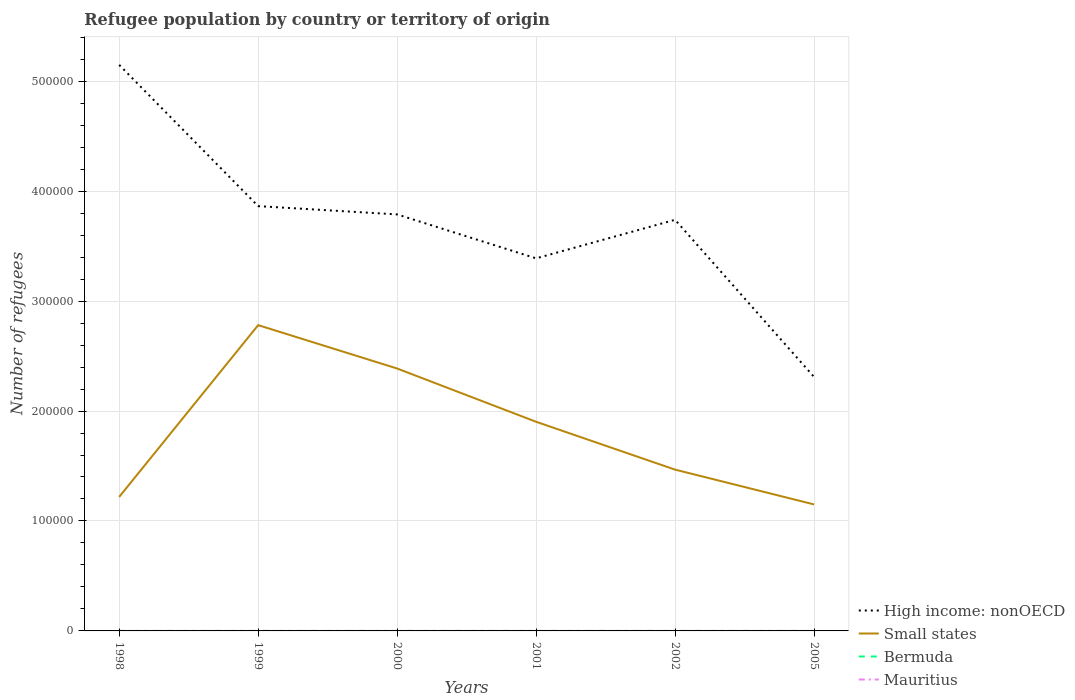How many different coloured lines are there?
Ensure brevity in your answer.  4. Is the number of lines equal to the number of legend labels?
Provide a short and direct response. Yes. Across all years, what is the maximum number of refugees in Mauritius?
Make the answer very short. 8. What is the total number of refugees in Small states in the graph?
Give a very brief answer. 1.24e+05. What is the difference between the highest and the second highest number of refugees in Mauritius?
Your response must be concise. 35. What is the difference between the highest and the lowest number of refugees in Small states?
Keep it short and to the point. 3. Is the number of refugees in Small states strictly greater than the number of refugees in Bermuda over the years?
Give a very brief answer. No. What is the difference between two consecutive major ticks on the Y-axis?
Provide a short and direct response. 1.00e+05. Are the values on the major ticks of Y-axis written in scientific E-notation?
Provide a short and direct response. No. Does the graph contain any zero values?
Provide a short and direct response. No. Does the graph contain grids?
Your response must be concise. Yes. Where does the legend appear in the graph?
Your response must be concise. Bottom right. How many legend labels are there?
Provide a succinct answer. 4. What is the title of the graph?
Offer a very short reply. Refugee population by country or territory of origin. Does "Luxembourg" appear as one of the legend labels in the graph?
Provide a short and direct response. No. What is the label or title of the X-axis?
Your answer should be very brief. Years. What is the label or title of the Y-axis?
Offer a terse response. Number of refugees. What is the Number of refugees of High income: nonOECD in 1998?
Offer a terse response. 5.15e+05. What is the Number of refugees of Small states in 1998?
Your answer should be compact. 1.22e+05. What is the Number of refugees of High income: nonOECD in 1999?
Your answer should be very brief. 3.86e+05. What is the Number of refugees of Small states in 1999?
Give a very brief answer. 2.78e+05. What is the Number of refugees in Bermuda in 1999?
Offer a terse response. 1. What is the Number of refugees in Mauritius in 1999?
Offer a very short reply. 8. What is the Number of refugees of High income: nonOECD in 2000?
Make the answer very short. 3.79e+05. What is the Number of refugees in Small states in 2000?
Offer a very short reply. 2.39e+05. What is the Number of refugees of High income: nonOECD in 2001?
Your response must be concise. 3.39e+05. What is the Number of refugees in Small states in 2001?
Offer a terse response. 1.90e+05. What is the Number of refugees in High income: nonOECD in 2002?
Offer a terse response. 3.74e+05. What is the Number of refugees in Small states in 2002?
Your answer should be compact. 1.47e+05. What is the Number of refugees in Bermuda in 2002?
Make the answer very short. 1. What is the Number of refugees of Mauritius in 2002?
Your answer should be compact. 43. What is the Number of refugees in High income: nonOECD in 2005?
Give a very brief answer. 2.31e+05. What is the Number of refugees of Small states in 2005?
Provide a short and direct response. 1.15e+05. What is the Number of refugees in Mauritius in 2005?
Your answer should be compact. 27. Across all years, what is the maximum Number of refugees of High income: nonOECD?
Make the answer very short. 5.15e+05. Across all years, what is the maximum Number of refugees of Small states?
Make the answer very short. 2.78e+05. Across all years, what is the maximum Number of refugees of Bermuda?
Your answer should be very brief. 2. Across all years, what is the minimum Number of refugees in High income: nonOECD?
Provide a succinct answer. 2.31e+05. Across all years, what is the minimum Number of refugees of Small states?
Give a very brief answer. 1.15e+05. Across all years, what is the minimum Number of refugees of Bermuda?
Ensure brevity in your answer.  1. What is the total Number of refugees in High income: nonOECD in the graph?
Provide a short and direct response. 2.22e+06. What is the total Number of refugees of Small states in the graph?
Give a very brief answer. 1.09e+06. What is the total Number of refugees in Bermuda in the graph?
Give a very brief answer. 7. What is the total Number of refugees of Mauritius in the graph?
Provide a succinct answer. 163. What is the difference between the Number of refugees of High income: nonOECD in 1998 and that in 1999?
Provide a succinct answer. 1.28e+05. What is the difference between the Number of refugees in Small states in 1998 and that in 1999?
Your response must be concise. -1.56e+05. What is the difference between the Number of refugees of Bermuda in 1998 and that in 1999?
Ensure brevity in your answer.  0. What is the difference between the Number of refugees of Mauritius in 1998 and that in 1999?
Offer a very short reply. 7. What is the difference between the Number of refugees in High income: nonOECD in 1998 and that in 2000?
Provide a succinct answer. 1.36e+05. What is the difference between the Number of refugees of Small states in 1998 and that in 2000?
Provide a succinct answer. -1.17e+05. What is the difference between the Number of refugees of Bermuda in 1998 and that in 2000?
Offer a terse response. 0. What is the difference between the Number of refugees in High income: nonOECD in 1998 and that in 2001?
Your response must be concise. 1.76e+05. What is the difference between the Number of refugees of Small states in 1998 and that in 2001?
Provide a succinct answer. -6.83e+04. What is the difference between the Number of refugees of Bermuda in 1998 and that in 2001?
Keep it short and to the point. 0. What is the difference between the Number of refugees of High income: nonOECD in 1998 and that in 2002?
Offer a terse response. 1.41e+05. What is the difference between the Number of refugees of Small states in 1998 and that in 2002?
Offer a very short reply. -2.48e+04. What is the difference between the Number of refugees in Mauritius in 1998 and that in 2002?
Provide a short and direct response. -28. What is the difference between the Number of refugees of High income: nonOECD in 1998 and that in 2005?
Offer a very short reply. 2.84e+05. What is the difference between the Number of refugees in Small states in 1998 and that in 2005?
Give a very brief answer. 6827. What is the difference between the Number of refugees of Bermuda in 1998 and that in 2005?
Ensure brevity in your answer.  -1. What is the difference between the Number of refugees in High income: nonOECD in 1999 and that in 2000?
Provide a succinct answer. 7527. What is the difference between the Number of refugees in Small states in 1999 and that in 2000?
Make the answer very short. 3.95e+04. What is the difference between the Number of refugees of High income: nonOECD in 1999 and that in 2001?
Make the answer very short. 4.75e+04. What is the difference between the Number of refugees of Small states in 1999 and that in 2001?
Your response must be concise. 8.79e+04. What is the difference between the Number of refugees of Mauritius in 1999 and that in 2001?
Give a very brief answer. -27. What is the difference between the Number of refugees of High income: nonOECD in 1999 and that in 2002?
Your response must be concise. 1.24e+04. What is the difference between the Number of refugees of Small states in 1999 and that in 2002?
Make the answer very short. 1.31e+05. What is the difference between the Number of refugees in Bermuda in 1999 and that in 2002?
Your response must be concise. 0. What is the difference between the Number of refugees of Mauritius in 1999 and that in 2002?
Give a very brief answer. -35. What is the difference between the Number of refugees of High income: nonOECD in 1999 and that in 2005?
Keep it short and to the point. 1.55e+05. What is the difference between the Number of refugees of Small states in 1999 and that in 2005?
Provide a short and direct response. 1.63e+05. What is the difference between the Number of refugees of Mauritius in 1999 and that in 2005?
Your answer should be compact. -19. What is the difference between the Number of refugees in High income: nonOECD in 2000 and that in 2001?
Your response must be concise. 4.00e+04. What is the difference between the Number of refugees in Small states in 2000 and that in 2001?
Offer a very short reply. 4.84e+04. What is the difference between the Number of refugees of Bermuda in 2000 and that in 2001?
Provide a succinct answer. 0. What is the difference between the Number of refugees of High income: nonOECD in 2000 and that in 2002?
Your answer should be compact. 4901. What is the difference between the Number of refugees in Small states in 2000 and that in 2002?
Keep it short and to the point. 9.20e+04. What is the difference between the Number of refugees of Bermuda in 2000 and that in 2002?
Ensure brevity in your answer.  0. What is the difference between the Number of refugees in Mauritius in 2000 and that in 2002?
Make the answer very short. -8. What is the difference between the Number of refugees of High income: nonOECD in 2000 and that in 2005?
Give a very brief answer. 1.48e+05. What is the difference between the Number of refugees of Small states in 2000 and that in 2005?
Provide a short and direct response. 1.24e+05. What is the difference between the Number of refugees of Mauritius in 2000 and that in 2005?
Give a very brief answer. 8. What is the difference between the Number of refugees of High income: nonOECD in 2001 and that in 2002?
Your answer should be very brief. -3.51e+04. What is the difference between the Number of refugees of Small states in 2001 and that in 2002?
Give a very brief answer. 4.35e+04. What is the difference between the Number of refugees of High income: nonOECD in 2001 and that in 2005?
Your answer should be compact. 1.08e+05. What is the difference between the Number of refugees in Small states in 2001 and that in 2005?
Your answer should be very brief. 7.52e+04. What is the difference between the Number of refugees of High income: nonOECD in 2002 and that in 2005?
Your answer should be very brief. 1.43e+05. What is the difference between the Number of refugees of Small states in 2002 and that in 2005?
Offer a terse response. 3.16e+04. What is the difference between the Number of refugees of Bermuda in 2002 and that in 2005?
Offer a very short reply. -1. What is the difference between the Number of refugees in High income: nonOECD in 1998 and the Number of refugees in Small states in 1999?
Offer a terse response. 2.37e+05. What is the difference between the Number of refugees in High income: nonOECD in 1998 and the Number of refugees in Bermuda in 1999?
Your answer should be compact. 5.15e+05. What is the difference between the Number of refugees of High income: nonOECD in 1998 and the Number of refugees of Mauritius in 1999?
Offer a very short reply. 5.15e+05. What is the difference between the Number of refugees in Small states in 1998 and the Number of refugees in Bermuda in 1999?
Your answer should be very brief. 1.22e+05. What is the difference between the Number of refugees of Small states in 1998 and the Number of refugees of Mauritius in 1999?
Give a very brief answer. 1.22e+05. What is the difference between the Number of refugees of High income: nonOECD in 1998 and the Number of refugees of Small states in 2000?
Provide a succinct answer. 2.76e+05. What is the difference between the Number of refugees in High income: nonOECD in 1998 and the Number of refugees in Bermuda in 2000?
Give a very brief answer. 5.15e+05. What is the difference between the Number of refugees of High income: nonOECD in 1998 and the Number of refugees of Mauritius in 2000?
Your response must be concise. 5.15e+05. What is the difference between the Number of refugees in Small states in 1998 and the Number of refugees in Bermuda in 2000?
Offer a terse response. 1.22e+05. What is the difference between the Number of refugees in Small states in 1998 and the Number of refugees in Mauritius in 2000?
Offer a very short reply. 1.22e+05. What is the difference between the Number of refugees of Bermuda in 1998 and the Number of refugees of Mauritius in 2000?
Ensure brevity in your answer.  -34. What is the difference between the Number of refugees of High income: nonOECD in 1998 and the Number of refugees of Small states in 2001?
Your response must be concise. 3.25e+05. What is the difference between the Number of refugees of High income: nonOECD in 1998 and the Number of refugees of Bermuda in 2001?
Offer a terse response. 5.15e+05. What is the difference between the Number of refugees of High income: nonOECD in 1998 and the Number of refugees of Mauritius in 2001?
Give a very brief answer. 5.15e+05. What is the difference between the Number of refugees of Small states in 1998 and the Number of refugees of Bermuda in 2001?
Offer a terse response. 1.22e+05. What is the difference between the Number of refugees of Small states in 1998 and the Number of refugees of Mauritius in 2001?
Provide a succinct answer. 1.22e+05. What is the difference between the Number of refugees of Bermuda in 1998 and the Number of refugees of Mauritius in 2001?
Your answer should be compact. -34. What is the difference between the Number of refugees of High income: nonOECD in 1998 and the Number of refugees of Small states in 2002?
Keep it short and to the point. 3.68e+05. What is the difference between the Number of refugees in High income: nonOECD in 1998 and the Number of refugees in Bermuda in 2002?
Your answer should be very brief. 5.15e+05. What is the difference between the Number of refugees of High income: nonOECD in 1998 and the Number of refugees of Mauritius in 2002?
Provide a short and direct response. 5.15e+05. What is the difference between the Number of refugees in Small states in 1998 and the Number of refugees in Bermuda in 2002?
Make the answer very short. 1.22e+05. What is the difference between the Number of refugees of Small states in 1998 and the Number of refugees of Mauritius in 2002?
Make the answer very short. 1.22e+05. What is the difference between the Number of refugees of Bermuda in 1998 and the Number of refugees of Mauritius in 2002?
Your answer should be compact. -42. What is the difference between the Number of refugees of High income: nonOECD in 1998 and the Number of refugees of Small states in 2005?
Make the answer very short. 4.00e+05. What is the difference between the Number of refugees in High income: nonOECD in 1998 and the Number of refugees in Bermuda in 2005?
Offer a terse response. 5.15e+05. What is the difference between the Number of refugees in High income: nonOECD in 1998 and the Number of refugees in Mauritius in 2005?
Give a very brief answer. 5.15e+05. What is the difference between the Number of refugees of Small states in 1998 and the Number of refugees of Bermuda in 2005?
Offer a terse response. 1.22e+05. What is the difference between the Number of refugees in Small states in 1998 and the Number of refugees in Mauritius in 2005?
Make the answer very short. 1.22e+05. What is the difference between the Number of refugees of Bermuda in 1998 and the Number of refugees of Mauritius in 2005?
Make the answer very short. -26. What is the difference between the Number of refugees of High income: nonOECD in 1999 and the Number of refugees of Small states in 2000?
Your response must be concise. 1.48e+05. What is the difference between the Number of refugees in High income: nonOECD in 1999 and the Number of refugees in Bermuda in 2000?
Make the answer very short. 3.86e+05. What is the difference between the Number of refugees in High income: nonOECD in 1999 and the Number of refugees in Mauritius in 2000?
Ensure brevity in your answer.  3.86e+05. What is the difference between the Number of refugees of Small states in 1999 and the Number of refugees of Bermuda in 2000?
Provide a succinct answer. 2.78e+05. What is the difference between the Number of refugees of Small states in 1999 and the Number of refugees of Mauritius in 2000?
Make the answer very short. 2.78e+05. What is the difference between the Number of refugees in Bermuda in 1999 and the Number of refugees in Mauritius in 2000?
Give a very brief answer. -34. What is the difference between the Number of refugees of High income: nonOECD in 1999 and the Number of refugees of Small states in 2001?
Your answer should be very brief. 1.96e+05. What is the difference between the Number of refugees in High income: nonOECD in 1999 and the Number of refugees in Bermuda in 2001?
Your answer should be very brief. 3.86e+05. What is the difference between the Number of refugees in High income: nonOECD in 1999 and the Number of refugees in Mauritius in 2001?
Keep it short and to the point. 3.86e+05. What is the difference between the Number of refugees of Small states in 1999 and the Number of refugees of Bermuda in 2001?
Your answer should be very brief. 2.78e+05. What is the difference between the Number of refugees in Small states in 1999 and the Number of refugees in Mauritius in 2001?
Keep it short and to the point. 2.78e+05. What is the difference between the Number of refugees in Bermuda in 1999 and the Number of refugees in Mauritius in 2001?
Make the answer very short. -34. What is the difference between the Number of refugees in High income: nonOECD in 1999 and the Number of refugees in Small states in 2002?
Offer a terse response. 2.40e+05. What is the difference between the Number of refugees of High income: nonOECD in 1999 and the Number of refugees of Bermuda in 2002?
Provide a short and direct response. 3.86e+05. What is the difference between the Number of refugees in High income: nonOECD in 1999 and the Number of refugees in Mauritius in 2002?
Ensure brevity in your answer.  3.86e+05. What is the difference between the Number of refugees in Small states in 1999 and the Number of refugees in Bermuda in 2002?
Keep it short and to the point. 2.78e+05. What is the difference between the Number of refugees in Small states in 1999 and the Number of refugees in Mauritius in 2002?
Your response must be concise. 2.78e+05. What is the difference between the Number of refugees in Bermuda in 1999 and the Number of refugees in Mauritius in 2002?
Your answer should be compact. -42. What is the difference between the Number of refugees of High income: nonOECD in 1999 and the Number of refugees of Small states in 2005?
Offer a very short reply. 2.71e+05. What is the difference between the Number of refugees in High income: nonOECD in 1999 and the Number of refugees in Bermuda in 2005?
Your answer should be very brief. 3.86e+05. What is the difference between the Number of refugees of High income: nonOECD in 1999 and the Number of refugees of Mauritius in 2005?
Your response must be concise. 3.86e+05. What is the difference between the Number of refugees of Small states in 1999 and the Number of refugees of Bermuda in 2005?
Your answer should be very brief. 2.78e+05. What is the difference between the Number of refugees in Small states in 1999 and the Number of refugees in Mauritius in 2005?
Keep it short and to the point. 2.78e+05. What is the difference between the Number of refugees in Bermuda in 1999 and the Number of refugees in Mauritius in 2005?
Offer a very short reply. -26. What is the difference between the Number of refugees of High income: nonOECD in 2000 and the Number of refugees of Small states in 2001?
Ensure brevity in your answer.  1.89e+05. What is the difference between the Number of refugees in High income: nonOECD in 2000 and the Number of refugees in Bermuda in 2001?
Give a very brief answer. 3.79e+05. What is the difference between the Number of refugees in High income: nonOECD in 2000 and the Number of refugees in Mauritius in 2001?
Provide a short and direct response. 3.79e+05. What is the difference between the Number of refugees of Small states in 2000 and the Number of refugees of Bermuda in 2001?
Your answer should be very brief. 2.39e+05. What is the difference between the Number of refugees of Small states in 2000 and the Number of refugees of Mauritius in 2001?
Your answer should be very brief. 2.39e+05. What is the difference between the Number of refugees in Bermuda in 2000 and the Number of refugees in Mauritius in 2001?
Provide a succinct answer. -34. What is the difference between the Number of refugees of High income: nonOECD in 2000 and the Number of refugees of Small states in 2002?
Your response must be concise. 2.32e+05. What is the difference between the Number of refugees of High income: nonOECD in 2000 and the Number of refugees of Bermuda in 2002?
Keep it short and to the point. 3.79e+05. What is the difference between the Number of refugees in High income: nonOECD in 2000 and the Number of refugees in Mauritius in 2002?
Your answer should be very brief. 3.79e+05. What is the difference between the Number of refugees in Small states in 2000 and the Number of refugees in Bermuda in 2002?
Give a very brief answer. 2.39e+05. What is the difference between the Number of refugees of Small states in 2000 and the Number of refugees of Mauritius in 2002?
Offer a terse response. 2.39e+05. What is the difference between the Number of refugees in Bermuda in 2000 and the Number of refugees in Mauritius in 2002?
Provide a short and direct response. -42. What is the difference between the Number of refugees in High income: nonOECD in 2000 and the Number of refugees in Small states in 2005?
Make the answer very short. 2.64e+05. What is the difference between the Number of refugees of High income: nonOECD in 2000 and the Number of refugees of Bermuda in 2005?
Give a very brief answer. 3.79e+05. What is the difference between the Number of refugees in High income: nonOECD in 2000 and the Number of refugees in Mauritius in 2005?
Provide a succinct answer. 3.79e+05. What is the difference between the Number of refugees of Small states in 2000 and the Number of refugees of Bermuda in 2005?
Your answer should be compact. 2.39e+05. What is the difference between the Number of refugees in Small states in 2000 and the Number of refugees in Mauritius in 2005?
Your response must be concise. 2.39e+05. What is the difference between the Number of refugees of High income: nonOECD in 2001 and the Number of refugees of Small states in 2002?
Provide a short and direct response. 1.92e+05. What is the difference between the Number of refugees of High income: nonOECD in 2001 and the Number of refugees of Bermuda in 2002?
Offer a very short reply. 3.39e+05. What is the difference between the Number of refugees of High income: nonOECD in 2001 and the Number of refugees of Mauritius in 2002?
Give a very brief answer. 3.39e+05. What is the difference between the Number of refugees in Small states in 2001 and the Number of refugees in Bermuda in 2002?
Offer a terse response. 1.90e+05. What is the difference between the Number of refugees of Small states in 2001 and the Number of refugees of Mauritius in 2002?
Give a very brief answer. 1.90e+05. What is the difference between the Number of refugees in Bermuda in 2001 and the Number of refugees in Mauritius in 2002?
Give a very brief answer. -42. What is the difference between the Number of refugees in High income: nonOECD in 2001 and the Number of refugees in Small states in 2005?
Provide a short and direct response. 2.24e+05. What is the difference between the Number of refugees of High income: nonOECD in 2001 and the Number of refugees of Bermuda in 2005?
Your answer should be compact. 3.39e+05. What is the difference between the Number of refugees of High income: nonOECD in 2001 and the Number of refugees of Mauritius in 2005?
Keep it short and to the point. 3.39e+05. What is the difference between the Number of refugees of Small states in 2001 and the Number of refugees of Bermuda in 2005?
Provide a succinct answer. 1.90e+05. What is the difference between the Number of refugees of Small states in 2001 and the Number of refugees of Mauritius in 2005?
Your answer should be very brief. 1.90e+05. What is the difference between the Number of refugees in High income: nonOECD in 2002 and the Number of refugees in Small states in 2005?
Your answer should be compact. 2.59e+05. What is the difference between the Number of refugees in High income: nonOECD in 2002 and the Number of refugees in Bermuda in 2005?
Make the answer very short. 3.74e+05. What is the difference between the Number of refugees in High income: nonOECD in 2002 and the Number of refugees in Mauritius in 2005?
Give a very brief answer. 3.74e+05. What is the difference between the Number of refugees in Small states in 2002 and the Number of refugees in Bermuda in 2005?
Provide a short and direct response. 1.47e+05. What is the difference between the Number of refugees in Small states in 2002 and the Number of refugees in Mauritius in 2005?
Your answer should be compact. 1.47e+05. What is the difference between the Number of refugees in Bermuda in 2002 and the Number of refugees in Mauritius in 2005?
Provide a succinct answer. -26. What is the average Number of refugees of High income: nonOECD per year?
Offer a terse response. 3.71e+05. What is the average Number of refugees in Small states per year?
Keep it short and to the point. 1.82e+05. What is the average Number of refugees of Mauritius per year?
Your answer should be very brief. 27.17. In the year 1998, what is the difference between the Number of refugees in High income: nonOECD and Number of refugees in Small states?
Your answer should be compact. 3.93e+05. In the year 1998, what is the difference between the Number of refugees in High income: nonOECD and Number of refugees in Bermuda?
Provide a short and direct response. 5.15e+05. In the year 1998, what is the difference between the Number of refugees in High income: nonOECD and Number of refugees in Mauritius?
Make the answer very short. 5.15e+05. In the year 1998, what is the difference between the Number of refugees in Small states and Number of refugees in Bermuda?
Offer a very short reply. 1.22e+05. In the year 1998, what is the difference between the Number of refugees of Small states and Number of refugees of Mauritius?
Give a very brief answer. 1.22e+05. In the year 1998, what is the difference between the Number of refugees of Bermuda and Number of refugees of Mauritius?
Your response must be concise. -14. In the year 1999, what is the difference between the Number of refugees of High income: nonOECD and Number of refugees of Small states?
Give a very brief answer. 1.08e+05. In the year 1999, what is the difference between the Number of refugees in High income: nonOECD and Number of refugees in Bermuda?
Provide a short and direct response. 3.86e+05. In the year 1999, what is the difference between the Number of refugees of High income: nonOECD and Number of refugees of Mauritius?
Your answer should be compact. 3.86e+05. In the year 1999, what is the difference between the Number of refugees of Small states and Number of refugees of Bermuda?
Provide a succinct answer. 2.78e+05. In the year 1999, what is the difference between the Number of refugees in Small states and Number of refugees in Mauritius?
Offer a terse response. 2.78e+05. In the year 2000, what is the difference between the Number of refugees of High income: nonOECD and Number of refugees of Small states?
Your answer should be very brief. 1.40e+05. In the year 2000, what is the difference between the Number of refugees of High income: nonOECD and Number of refugees of Bermuda?
Your response must be concise. 3.79e+05. In the year 2000, what is the difference between the Number of refugees in High income: nonOECD and Number of refugees in Mauritius?
Keep it short and to the point. 3.79e+05. In the year 2000, what is the difference between the Number of refugees in Small states and Number of refugees in Bermuda?
Offer a terse response. 2.39e+05. In the year 2000, what is the difference between the Number of refugees of Small states and Number of refugees of Mauritius?
Ensure brevity in your answer.  2.39e+05. In the year 2000, what is the difference between the Number of refugees of Bermuda and Number of refugees of Mauritius?
Your response must be concise. -34. In the year 2001, what is the difference between the Number of refugees of High income: nonOECD and Number of refugees of Small states?
Your response must be concise. 1.49e+05. In the year 2001, what is the difference between the Number of refugees in High income: nonOECD and Number of refugees in Bermuda?
Your answer should be compact. 3.39e+05. In the year 2001, what is the difference between the Number of refugees in High income: nonOECD and Number of refugees in Mauritius?
Give a very brief answer. 3.39e+05. In the year 2001, what is the difference between the Number of refugees in Small states and Number of refugees in Bermuda?
Ensure brevity in your answer.  1.90e+05. In the year 2001, what is the difference between the Number of refugees of Small states and Number of refugees of Mauritius?
Provide a short and direct response. 1.90e+05. In the year 2001, what is the difference between the Number of refugees of Bermuda and Number of refugees of Mauritius?
Provide a succinct answer. -34. In the year 2002, what is the difference between the Number of refugees in High income: nonOECD and Number of refugees in Small states?
Provide a succinct answer. 2.27e+05. In the year 2002, what is the difference between the Number of refugees in High income: nonOECD and Number of refugees in Bermuda?
Ensure brevity in your answer.  3.74e+05. In the year 2002, what is the difference between the Number of refugees of High income: nonOECD and Number of refugees of Mauritius?
Your response must be concise. 3.74e+05. In the year 2002, what is the difference between the Number of refugees in Small states and Number of refugees in Bermuda?
Your answer should be very brief. 1.47e+05. In the year 2002, what is the difference between the Number of refugees of Small states and Number of refugees of Mauritius?
Keep it short and to the point. 1.47e+05. In the year 2002, what is the difference between the Number of refugees of Bermuda and Number of refugees of Mauritius?
Offer a terse response. -42. In the year 2005, what is the difference between the Number of refugees of High income: nonOECD and Number of refugees of Small states?
Provide a succinct answer. 1.16e+05. In the year 2005, what is the difference between the Number of refugees of High income: nonOECD and Number of refugees of Bermuda?
Your response must be concise. 2.31e+05. In the year 2005, what is the difference between the Number of refugees of High income: nonOECD and Number of refugees of Mauritius?
Give a very brief answer. 2.31e+05. In the year 2005, what is the difference between the Number of refugees in Small states and Number of refugees in Bermuda?
Offer a very short reply. 1.15e+05. In the year 2005, what is the difference between the Number of refugees of Small states and Number of refugees of Mauritius?
Your answer should be compact. 1.15e+05. What is the ratio of the Number of refugees of High income: nonOECD in 1998 to that in 1999?
Offer a very short reply. 1.33. What is the ratio of the Number of refugees in Small states in 1998 to that in 1999?
Offer a terse response. 0.44. What is the ratio of the Number of refugees in Bermuda in 1998 to that in 1999?
Make the answer very short. 1. What is the ratio of the Number of refugees in Mauritius in 1998 to that in 1999?
Give a very brief answer. 1.88. What is the ratio of the Number of refugees in High income: nonOECD in 1998 to that in 2000?
Your answer should be very brief. 1.36. What is the ratio of the Number of refugees of Small states in 1998 to that in 2000?
Provide a succinct answer. 0.51. What is the ratio of the Number of refugees in Bermuda in 1998 to that in 2000?
Ensure brevity in your answer.  1. What is the ratio of the Number of refugees of Mauritius in 1998 to that in 2000?
Your answer should be compact. 0.43. What is the ratio of the Number of refugees of High income: nonOECD in 1998 to that in 2001?
Offer a very short reply. 1.52. What is the ratio of the Number of refugees in Small states in 1998 to that in 2001?
Ensure brevity in your answer.  0.64. What is the ratio of the Number of refugees in Mauritius in 1998 to that in 2001?
Ensure brevity in your answer.  0.43. What is the ratio of the Number of refugees in High income: nonOECD in 1998 to that in 2002?
Offer a very short reply. 1.38. What is the ratio of the Number of refugees of Small states in 1998 to that in 2002?
Provide a succinct answer. 0.83. What is the ratio of the Number of refugees in Mauritius in 1998 to that in 2002?
Ensure brevity in your answer.  0.35. What is the ratio of the Number of refugees of High income: nonOECD in 1998 to that in 2005?
Provide a succinct answer. 2.23. What is the ratio of the Number of refugees of Small states in 1998 to that in 2005?
Make the answer very short. 1.06. What is the ratio of the Number of refugees in Bermuda in 1998 to that in 2005?
Make the answer very short. 0.5. What is the ratio of the Number of refugees of Mauritius in 1998 to that in 2005?
Keep it short and to the point. 0.56. What is the ratio of the Number of refugees in High income: nonOECD in 1999 to that in 2000?
Provide a succinct answer. 1.02. What is the ratio of the Number of refugees of Small states in 1999 to that in 2000?
Provide a short and direct response. 1.17. What is the ratio of the Number of refugees of Bermuda in 1999 to that in 2000?
Your response must be concise. 1. What is the ratio of the Number of refugees of Mauritius in 1999 to that in 2000?
Your answer should be very brief. 0.23. What is the ratio of the Number of refugees in High income: nonOECD in 1999 to that in 2001?
Make the answer very short. 1.14. What is the ratio of the Number of refugees in Small states in 1999 to that in 2001?
Make the answer very short. 1.46. What is the ratio of the Number of refugees in Mauritius in 1999 to that in 2001?
Give a very brief answer. 0.23. What is the ratio of the Number of refugees of High income: nonOECD in 1999 to that in 2002?
Provide a short and direct response. 1.03. What is the ratio of the Number of refugees of Small states in 1999 to that in 2002?
Provide a short and direct response. 1.9. What is the ratio of the Number of refugees of Mauritius in 1999 to that in 2002?
Offer a very short reply. 0.19. What is the ratio of the Number of refugees of High income: nonOECD in 1999 to that in 2005?
Provide a short and direct response. 1.67. What is the ratio of the Number of refugees of Small states in 1999 to that in 2005?
Provide a succinct answer. 2.42. What is the ratio of the Number of refugees in Bermuda in 1999 to that in 2005?
Your answer should be very brief. 0.5. What is the ratio of the Number of refugees of Mauritius in 1999 to that in 2005?
Offer a terse response. 0.3. What is the ratio of the Number of refugees of High income: nonOECD in 2000 to that in 2001?
Make the answer very short. 1.12. What is the ratio of the Number of refugees in Small states in 2000 to that in 2001?
Your answer should be compact. 1.25. What is the ratio of the Number of refugees in High income: nonOECD in 2000 to that in 2002?
Offer a very short reply. 1.01. What is the ratio of the Number of refugees of Small states in 2000 to that in 2002?
Ensure brevity in your answer.  1.63. What is the ratio of the Number of refugees of Bermuda in 2000 to that in 2002?
Ensure brevity in your answer.  1. What is the ratio of the Number of refugees of Mauritius in 2000 to that in 2002?
Your answer should be very brief. 0.81. What is the ratio of the Number of refugees in High income: nonOECD in 2000 to that in 2005?
Offer a very short reply. 1.64. What is the ratio of the Number of refugees of Small states in 2000 to that in 2005?
Provide a short and direct response. 2.07. What is the ratio of the Number of refugees in Bermuda in 2000 to that in 2005?
Provide a short and direct response. 0.5. What is the ratio of the Number of refugees of Mauritius in 2000 to that in 2005?
Ensure brevity in your answer.  1.3. What is the ratio of the Number of refugees in High income: nonOECD in 2001 to that in 2002?
Your answer should be very brief. 0.91. What is the ratio of the Number of refugees of Small states in 2001 to that in 2002?
Keep it short and to the point. 1.3. What is the ratio of the Number of refugees in Mauritius in 2001 to that in 2002?
Make the answer very short. 0.81. What is the ratio of the Number of refugees of High income: nonOECD in 2001 to that in 2005?
Offer a terse response. 1.47. What is the ratio of the Number of refugees in Small states in 2001 to that in 2005?
Give a very brief answer. 1.65. What is the ratio of the Number of refugees in Mauritius in 2001 to that in 2005?
Provide a succinct answer. 1.3. What is the ratio of the Number of refugees in High income: nonOECD in 2002 to that in 2005?
Your answer should be very brief. 1.62. What is the ratio of the Number of refugees of Small states in 2002 to that in 2005?
Your response must be concise. 1.28. What is the ratio of the Number of refugees in Bermuda in 2002 to that in 2005?
Give a very brief answer. 0.5. What is the ratio of the Number of refugees in Mauritius in 2002 to that in 2005?
Offer a terse response. 1.59. What is the difference between the highest and the second highest Number of refugees in High income: nonOECD?
Provide a short and direct response. 1.28e+05. What is the difference between the highest and the second highest Number of refugees in Small states?
Offer a terse response. 3.95e+04. What is the difference between the highest and the second highest Number of refugees of Bermuda?
Provide a short and direct response. 1. What is the difference between the highest and the lowest Number of refugees of High income: nonOECD?
Provide a short and direct response. 2.84e+05. What is the difference between the highest and the lowest Number of refugees of Small states?
Give a very brief answer. 1.63e+05. What is the difference between the highest and the lowest Number of refugees of Mauritius?
Ensure brevity in your answer.  35. 